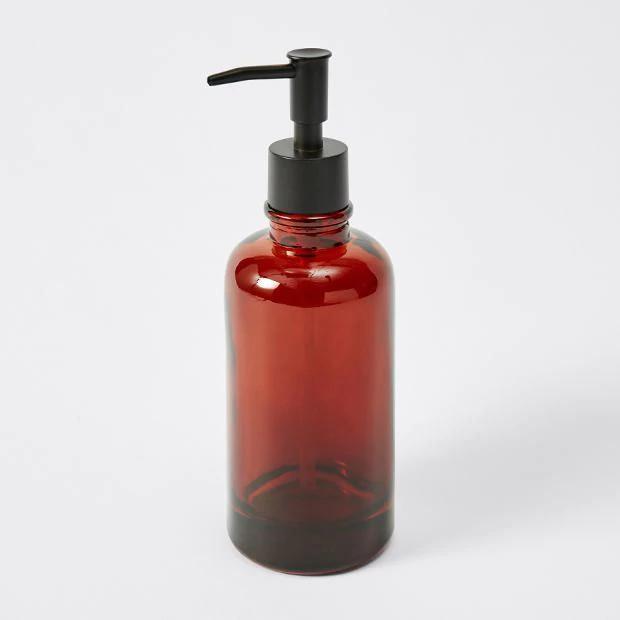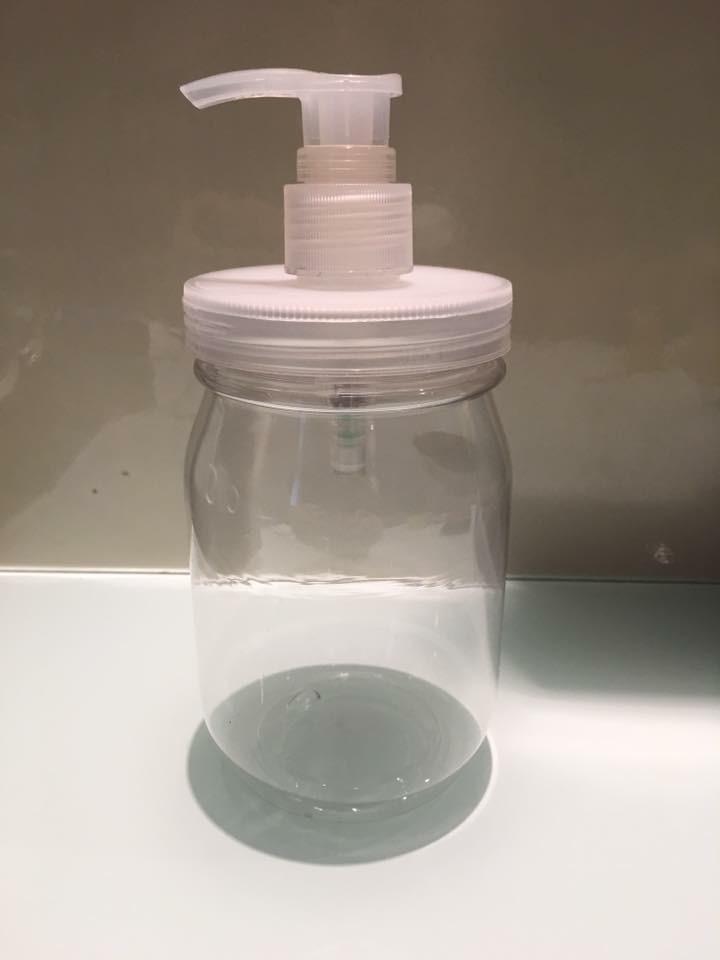The first image is the image on the left, the second image is the image on the right. For the images displayed, is the sentence "The right image is an empty soap dispenser facing to the right." factually correct? Answer yes or no. No. The first image is the image on the left, the second image is the image on the right. Analyze the images presented: Is the assertion "The dispenser in both pictures is pointing toward the left." valid? Answer yes or no. Yes. 